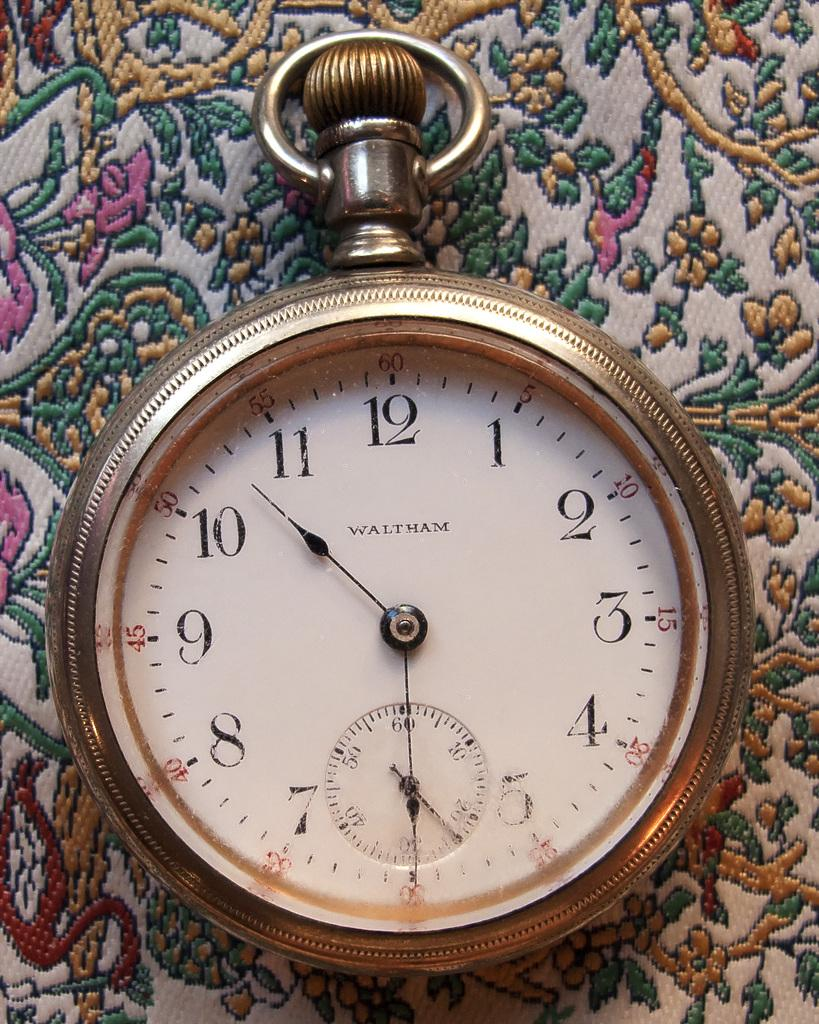Provide a one-sentence caption for the provided image. A pocketwatch by the brand Waltham displays the time 10:30. 